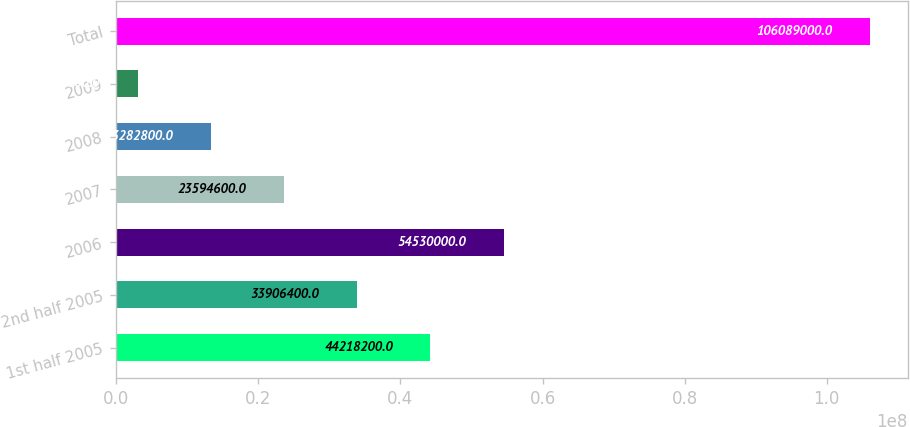<chart> <loc_0><loc_0><loc_500><loc_500><bar_chart><fcel>1st half 2005<fcel>2nd half 2005<fcel>2006<fcel>2007<fcel>2008<fcel>2009<fcel>Total<nl><fcel>4.42182e+07<fcel>3.39064e+07<fcel>5.453e+07<fcel>2.35946e+07<fcel>1.32828e+07<fcel>2.971e+06<fcel>1.06089e+08<nl></chart> 